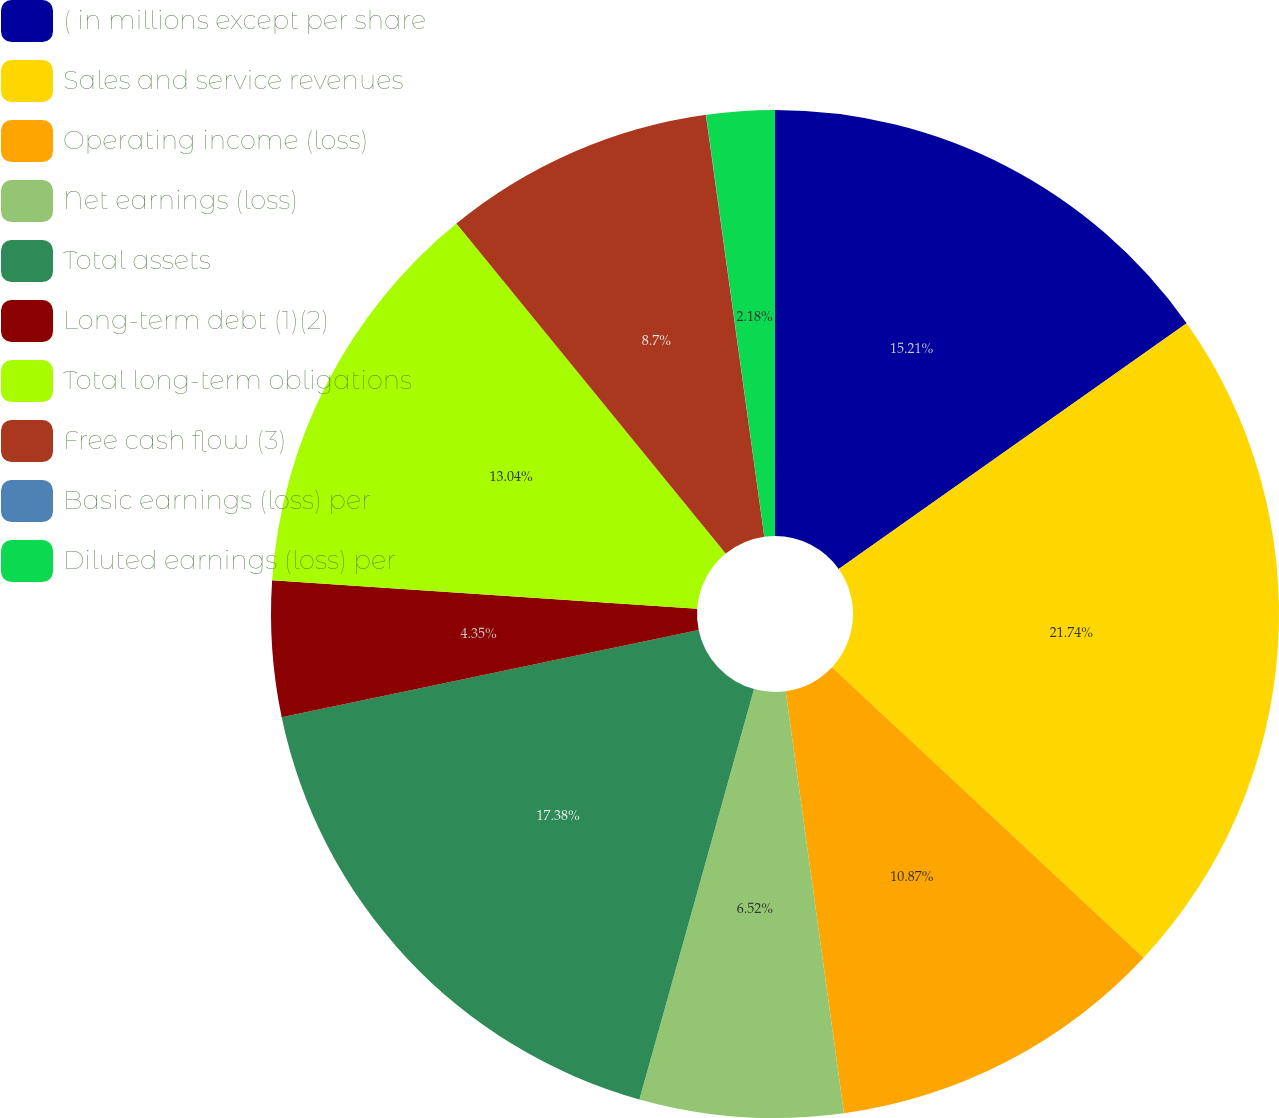Convert chart to OTSL. <chart><loc_0><loc_0><loc_500><loc_500><pie_chart><fcel>( in millions except per share<fcel>Sales and service revenues<fcel>Operating income (loss)<fcel>Net earnings (loss)<fcel>Total assets<fcel>Long-term debt (1)(2)<fcel>Total long-term obligations<fcel>Free cash flow (3)<fcel>Basic earnings (loss) per<fcel>Diluted earnings (loss) per<nl><fcel>15.21%<fcel>21.73%<fcel>10.87%<fcel>6.52%<fcel>17.38%<fcel>4.35%<fcel>13.04%<fcel>8.7%<fcel>0.01%<fcel>2.18%<nl></chart> 